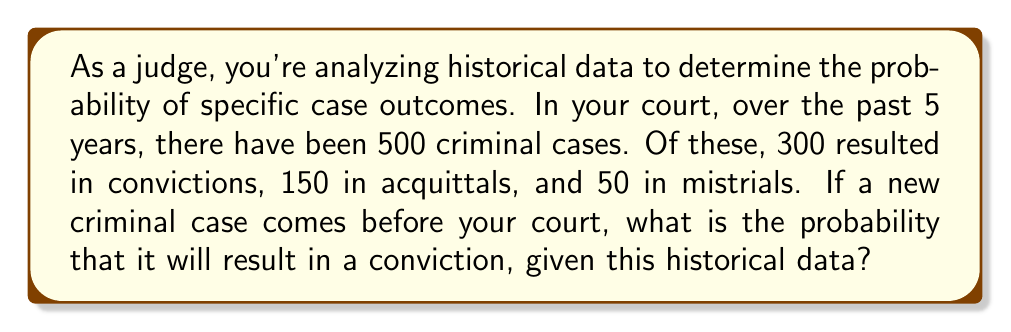Solve this math problem. To solve this problem, we'll use the concept of relative frequency as an estimate of probability. Here's the step-by-step solution:

1) First, let's identify the total number of cases and the number of convictions:
   Total cases: $n = 500$
   Convictions: $k = 300$

2) The probability of a conviction can be estimated by the relative frequency:

   $P(\text{Conviction}) = \frac{\text{Number of favorable outcomes}}{\text{Total number of possible outcomes}}$

3) Substituting our values:

   $P(\text{Conviction}) = \frac{k}{n} = \frac{300}{500}$

4) Simplify the fraction:

   $P(\text{Conviction}) = \frac{3}{5} = 0.6$

5) Convert to a percentage:

   $P(\text{Conviction}) = 0.6 \times 100\% = 60\%$

Therefore, based on the historical data, the probability that a new criminal case will result in a conviction is 60% or 0.6.
Answer: $\frac{3}{5}$ or $0.6$ or $60\%$ 